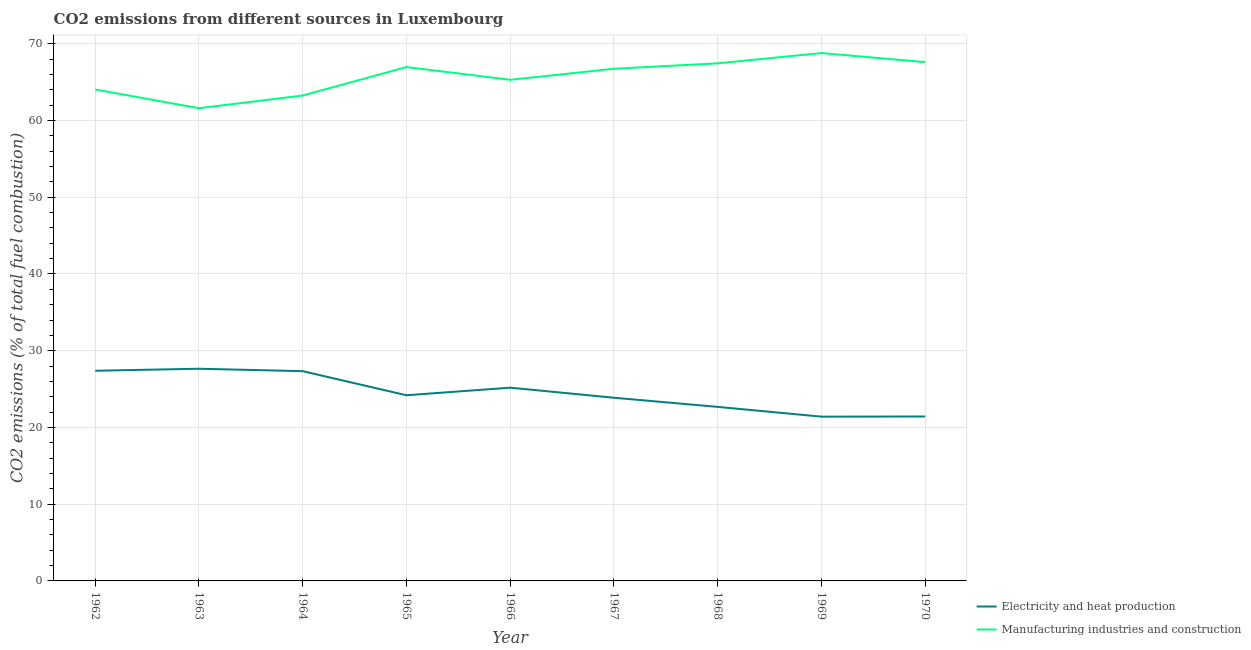What is the co2 emissions due to manufacturing industries in 1969?
Your answer should be very brief. 68.79. Across all years, what is the maximum co2 emissions due to manufacturing industries?
Give a very brief answer. 68.79. Across all years, what is the minimum co2 emissions due to manufacturing industries?
Offer a terse response. 61.6. In which year was the co2 emissions due to manufacturing industries maximum?
Provide a short and direct response. 1969. In which year was the co2 emissions due to manufacturing industries minimum?
Offer a very short reply. 1963. What is the total co2 emissions due to manufacturing industries in the graph?
Offer a terse response. 591.81. What is the difference between the co2 emissions due to manufacturing industries in 1963 and that in 1970?
Your response must be concise. -6.01. What is the difference between the co2 emissions due to electricity and heat production in 1967 and the co2 emissions due to manufacturing industries in 1968?
Offer a very short reply. -43.58. What is the average co2 emissions due to manufacturing industries per year?
Your response must be concise. 65.76. In the year 1970, what is the difference between the co2 emissions due to electricity and heat production and co2 emissions due to manufacturing industries?
Give a very brief answer. -46.19. In how many years, is the co2 emissions due to manufacturing industries greater than 38 %?
Provide a short and direct response. 9. What is the ratio of the co2 emissions due to manufacturing industries in 1965 to that in 1966?
Provide a succinct answer. 1.03. Is the co2 emissions due to manufacturing industries in 1966 less than that in 1968?
Make the answer very short. Yes. Is the difference between the co2 emissions due to manufacturing industries in 1968 and 1970 greater than the difference between the co2 emissions due to electricity and heat production in 1968 and 1970?
Provide a succinct answer. No. What is the difference between the highest and the second highest co2 emissions due to electricity and heat production?
Your answer should be compact. 0.26. What is the difference between the highest and the lowest co2 emissions due to manufacturing industries?
Your answer should be compact. 7.19. In how many years, is the co2 emissions due to electricity and heat production greater than the average co2 emissions due to electricity and heat production taken over all years?
Offer a terse response. 4. Does the co2 emissions due to manufacturing industries monotonically increase over the years?
Offer a very short reply. No. Is the co2 emissions due to electricity and heat production strictly greater than the co2 emissions due to manufacturing industries over the years?
Offer a very short reply. No. Is the co2 emissions due to manufacturing industries strictly less than the co2 emissions due to electricity and heat production over the years?
Your answer should be very brief. No. How many lines are there?
Your answer should be very brief. 2. Does the graph contain any zero values?
Keep it short and to the point. No. What is the title of the graph?
Your response must be concise. CO2 emissions from different sources in Luxembourg. Does "Current education expenditure" appear as one of the legend labels in the graph?
Your response must be concise. No. What is the label or title of the X-axis?
Your answer should be compact. Year. What is the label or title of the Y-axis?
Provide a short and direct response. CO2 emissions (% of total fuel combustion). What is the CO2 emissions (% of total fuel combustion) in Electricity and heat production in 1962?
Your answer should be compact. 27.39. What is the CO2 emissions (% of total fuel combustion) of Manufacturing industries and construction in 1962?
Your response must be concise. 64.05. What is the CO2 emissions (% of total fuel combustion) of Electricity and heat production in 1963?
Make the answer very short. 27.65. What is the CO2 emissions (% of total fuel combustion) in Manufacturing industries and construction in 1963?
Your answer should be compact. 61.6. What is the CO2 emissions (% of total fuel combustion) in Electricity and heat production in 1964?
Offer a very short reply. 27.34. What is the CO2 emissions (% of total fuel combustion) in Manufacturing industries and construction in 1964?
Ensure brevity in your answer.  63.26. What is the CO2 emissions (% of total fuel combustion) in Electricity and heat production in 1965?
Provide a short and direct response. 24.2. What is the CO2 emissions (% of total fuel combustion) of Manufacturing industries and construction in 1965?
Your answer should be very brief. 66.97. What is the CO2 emissions (% of total fuel combustion) of Electricity and heat production in 1966?
Your response must be concise. 25.19. What is the CO2 emissions (% of total fuel combustion) in Manufacturing industries and construction in 1966?
Your answer should be compact. 65.31. What is the CO2 emissions (% of total fuel combustion) of Electricity and heat production in 1967?
Ensure brevity in your answer.  23.87. What is the CO2 emissions (% of total fuel combustion) of Manufacturing industries and construction in 1967?
Your answer should be compact. 66.75. What is the CO2 emissions (% of total fuel combustion) in Electricity and heat production in 1968?
Keep it short and to the point. 22.68. What is the CO2 emissions (% of total fuel combustion) in Manufacturing industries and construction in 1968?
Your answer should be compact. 67.45. What is the CO2 emissions (% of total fuel combustion) in Electricity and heat production in 1969?
Provide a succinct answer. 21.41. What is the CO2 emissions (% of total fuel combustion) of Manufacturing industries and construction in 1969?
Offer a terse response. 68.79. What is the CO2 emissions (% of total fuel combustion) of Electricity and heat production in 1970?
Your answer should be compact. 21.43. What is the CO2 emissions (% of total fuel combustion) of Manufacturing industries and construction in 1970?
Ensure brevity in your answer.  67.62. Across all years, what is the maximum CO2 emissions (% of total fuel combustion) of Electricity and heat production?
Your answer should be compact. 27.65. Across all years, what is the maximum CO2 emissions (% of total fuel combustion) of Manufacturing industries and construction?
Offer a very short reply. 68.79. Across all years, what is the minimum CO2 emissions (% of total fuel combustion) in Electricity and heat production?
Ensure brevity in your answer.  21.41. Across all years, what is the minimum CO2 emissions (% of total fuel combustion) of Manufacturing industries and construction?
Provide a succinct answer. 61.6. What is the total CO2 emissions (% of total fuel combustion) in Electricity and heat production in the graph?
Provide a succinct answer. 221.15. What is the total CO2 emissions (% of total fuel combustion) of Manufacturing industries and construction in the graph?
Provide a succinct answer. 591.81. What is the difference between the CO2 emissions (% of total fuel combustion) in Electricity and heat production in 1962 and that in 1963?
Ensure brevity in your answer.  -0.26. What is the difference between the CO2 emissions (% of total fuel combustion) in Manufacturing industries and construction in 1962 and that in 1963?
Provide a short and direct response. 2.44. What is the difference between the CO2 emissions (% of total fuel combustion) in Electricity and heat production in 1962 and that in 1964?
Your answer should be compact. 0.06. What is the difference between the CO2 emissions (% of total fuel combustion) in Manufacturing industries and construction in 1962 and that in 1964?
Your answer should be very brief. 0.79. What is the difference between the CO2 emissions (% of total fuel combustion) in Electricity and heat production in 1962 and that in 1965?
Make the answer very short. 3.19. What is the difference between the CO2 emissions (% of total fuel combustion) of Manufacturing industries and construction in 1962 and that in 1965?
Provide a short and direct response. -2.92. What is the difference between the CO2 emissions (% of total fuel combustion) in Electricity and heat production in 1962 and that in 1966?
Your response must be concise. 2.21. What is the difference between the CO2 emissions (% of total fuel combustion) in Manufacturing industries and construction in 1962 and that in 1966?
Your answer should be very brief. -1.26. What is the difference between the CO2 emissions (% of total fuel combustion) of Electricity and heat production in 1962 and that in 1967?
Offer a terse response. 3.52. What is the difference between the CO2 emissions (% of total fuel combustion) of Manufacturing industries and construction in 1962 and that in 1967?
Your answer should be very brief. -2.7. What is the difference between the CO2 emissions (% of total fuel combustion) in Electricity and heat production in 1962 and that in 1968?
Provide a succinct answer. 4.71. What is the difference between the CO2 emissions (% of total fuel combustion) in Manufacturing industries and construction in 1962 and that in 1968?
Keep it short and to the point. -3.4. What is the difference between the CO2 emissions (% of total fuel combustion) in Electricity and heat production in 1962 and that in 1969?
Make the answer very short. 5.98. What is the difference between the CO2 emissions (% of total fuel combustion) in Manufacturing industries and construction in 1962 and that in 1969?
Your answer should be very brief. -4.75. What is the difference between the CO2 emissions (% of total fuel combustion) of Electricity and heat production in 1962 and that in 1970?
Make the answer very short. 5.96. What is the difference between the CO2 emissions (% of total fuel combustion) of Manufacturing industries and construction in 1962 and that in 1970?
Make the answer very short. -3.57. What is the difference between the CO2 emissions (% of total fuel combustion) in Electricity and heat production in 1963 and that in 1964?
Offer a very short reply. 0.32. What is the difference between the CO2 emissions (% of total fuel combustion) in Manufacturing industries and construction in 1963 and that in 1964?
Offer a terse response. -1.66. What is the difference between the CO2 emissions (% of total fuel combustion) of Electricity and heat production in 1963 and that in 1965?
Make the answer very short. 3.46. What is the difference between the CO2 emissions (% of total fuel combustion) in Manufacturing industries and construction in 1963 and that in 1965?
Offer a terse response. -5.37. What is the difference between the CO2 emissions (% of total fuel combustion) in Electricity and heat production in 1963 and that in 1966?
Your answer should be very brief. 2.47. What is the difference between the CO2 emissions (% of total fuel combustion) in Manufacturing industries and construction in 1963 and that in 1966?
Your answer should be very brief. -3.7. What is the difference between the CO2 emissions (% of total fuel combustion) of Electricity and heat production in 1963 and that in 1967?
Ensure brevity in your answer.  3.78. What is the difference between the CO2 emissions (% of total fuel combustion) of Manufacturing industries and construction in 1963 and that in 1967?
Ensure brevity in your answer.  -5.14. What is the difference between the CO2 emissions (% of total fuel combustion) of Electricity and heat production in 1963 and that in 1968?
Offer a very short reply. 4.97. What is the difference between the CO2 emissions (% of total fuel combustion) of Manufacturing industries and construction in 1963 and that in 1968?
Offer a terse response. -5.85. What is the difference between the CO2 emissions (% of total fuel combustion) in Electricity and heat production in 1963 and that in 1969?
Offer a very short reply. 6.24. What is the difference between the CO2 emissions (% of total fuel combustion) of Manufacturing industries and construction in 1963 and that in 1969?
Make the answer very short. -7.19. What is the difference between the CO2 emissions (% of total fuel combustion) in Electricity and heat production in 1963 and that in 1970?
Provide a short and direct response. 6.22. What is the difference between the CO2 emissions (% of total fuel combustion) in Manufacturing industries and construction in 1963 and that in 1970?
Give a very brief answer. -6.01. What is the difference between the CO2 emissions (% of total fuel combustion) of Electricity and heat production in 1964 and that in 1965?
Offer a terse response. 3.14. What is the difference between the CO2 emissions (% of total fuel combustion) of Manufacturing industries and construction in 1964 and that in 1965?
Offer a very short reply. -3.71. What is the difference between the CO2 emissions (% of total fuel combustion) of Electricity and heat production in 1964 and that in 1966?
Provide a succinct answer. 2.15. What is the difference between the CO2 emissions (% of total fuel combustion) in Manufacturing industries and construction in 1964 and that in 1966?
Make the answer very short. -2.05. What is the difference between the CO2 emissions (% of total fuel combustion) in Electricity and heat production in 1964 and that in 1967?
Provide a short and direct response. 3.46. What is the difference between the CO2 emissions (% of total fuel combustion) in Manufacturing industries and construction in 1964 and that in 1967?
Ensure brevity in your answer.  -3.49. What is the difference between the CO2 emissions (% of total fuel combustion) in Electricity and heat production in 1964 and that in 1968?
Keep it short and to the point. 4.65. What is the difference between the CO2 emissions (% of total fuel combustion) of Manufacturing industries and construction in 1964 and that in 1968?
Your answer should be very brief. -4.19. What is the difference between the CO2 emissions (% of total fuel combustion) of Electricity and heat production in 1964 and that in 1969?
Your response must be concise. 5.93. What is the difference between the CO2 emissions (% of total fuel combustion) of Manufacturing industries and construction in 1964 and that in 1969?
Keep it short and to the point. -5.53. What is the difference between the CO2 emissions (% of total fuel combustion) of Electricity and heat production in 1964 and that in 1970?
Your answer should be very brief. 5.91. What is the difference between the CO2 emissions (% of total fuel combustion) of Manufacturing industries and construction in 1964 and that in 1970?
Your response must be concise. -4.35. What is the difference between the CO2 emissions (% of total fuel combustion) in Electricity and heat production in 1965 and that in 1966?
Provide a short and direct response. -0.99. What is the difference between the CO2 emissions (% of total fuel combustion) of Manufacturing industries and construction in 1965 and that in 1966?
Give a very brief answer. 1.66. What is the difference between the CO2 emissions (% of total fuel combustion) of Electricity and heat production in 1965 and that in 1967?
Provide a succinct answer. 0.32. What is the difference between the CO2 emissions (% of total fuel combustion) in Manufacturing industries and construction in 1965 and that in 1967?
Provide a short and direct response. 0.22. What is the difference between the CO2 emissions (% of total fuel combustion) in Electricity and heat production in 1965 and that in 1968?
Keep it short and to the point. 1.52. What is the difference between the CO2 emissions (% of total fuel combustion) of Manufacturing industries and construction in 1965 and that in 1968?
Your response must be concise. -0.48. What is the difference between the CO2 emissions (% of total fuel combustion) of Electricity and heat production in 1965 and that in 1969?
Your answer should be compact. 2.79. What is the difference between the CO2 emissions (% of total fuel combustion) of Manufacturing industries and construction in 1965 and that in 1969?
Provide a succinct answer. -1.82. What is the difference between the CO2 emissions (% of total fuel combustion) of Electricity and heat production in 1965 and that in 1970?
Make the answer very short. 2.77. What is the difference between the CO2 emissions (% of total fuel combustion) in Manufacturing industries and construction in 1965 and that in 1970?
Your response must be concise. -0.64. What is the difference between the CO2 emissions (% of total fuel combustion) of Electricity and heat production in 1966 and that in 1967?
Your answer should be very brief. 1.31. What is the difference between the CO2 emissions (% of total fuel combustion) of Manufacturing industries and construction in 1966 and that in 1967?
Keep it short and to the point. -1.44. What is the difference between the CO2 emissions (% of total fuel combustion) of Electricity and heat production in 1966 and that in 1968?
Your answer should be compact. 2.5. What is the difference between the CO2 emissions (% of total fuel combustion) of Manufacturing industries and construction in 1966 and that in 1968?
Give a very brief answer. -2.15. What is the difference between the CO2 emissions (% of total fuel combustion) of Electricity and heat production in 1966 and that in 1969?
Ensure brevity in your answer.  3.78. What is the difference between the CO2 emissions (% of total fuel combustion) in Manufacturing industries and construction in 1966 and that in 1969?
Provide a succinct answer. -3.49. What is the difference between the CO2 emissions (% of total fuel combustion) in Electricity and heat production in 1966 and that in 1970?
Provide a succinct answer. 3.76. What is the difference between the CO2 emissions (% of total fuel combustion) in Manufacturing industries and construction in 1966 and that in 1970?
Give a very brief answer. -2.31. What is the difference between the CO2 emissions (% of total fuel combustion) of Electricity and heat production in 1967 and that in 1968?
Your answer should be very brief. 1.19. What is the difference between the CO2 emissions (% of total fuel combustion) in Manufacturing industries and construction in 1967 and that in 1968?
Provide a short and direct response. -0.71. What is the difference between the CO2 emissions (% of total fuel combustion) of Electricity and heat production in 1967 and that in 1969?
Provide a succinct answer. 2.47. What is the difference between the CO2 emissions (% of total fuel combustion) of Manufacturing industries and construction in 1967 and that in 1969?
Provide a succinct answer. -2.05. What is the difference between the CO2 emissions (% of total fuel combustion) of Electricity and heat production in 1967 and that in 1970?
Provide a short and direct response. 2.45. What is the difference between the CO2 emissions (% of total fuel combustion) in Manufacturing industries and construction in 1967 and that in 1970?
Ensure brevity in your answer.  -0.87. What is the difference between the CO2 emissions (% of total fuel combustion) of Electricity and heat production in 1968 and that in 1969?
Keep it short and to the point. 1.27. What is the difference between the CO2 emissions (% of total fuel combustion) in Manufacturing industries and construction in 1968 and that in 1969?
Provide a short and direct response. -1.34. What is the difference between the CO2 emissions (% of total fuel combustion) in Electricity and heat production in 1968 and that in 1970?
Your answer should be compact. 1.25. What is the difference between the CO2 emissions (% of total fuel combustion) of Manufacturing industries and construction in 1968 and that in 1970?
Offer a very short reply. -0.16. What is the difference between the CO2 emissions (% of total fuel combustion) of Electricity and heat production in 1969 and that in 1970?
Offer a very short reply. -0.02. What is the difference between the CO2 emissions (% of total fuel combustion) in Manufacturing industries and construction in 1969 and that in 1970?
Ensure brevity in your answer.  1.18. What is the difference between the CO2 emissions (% of total fuel combustion) in Electricity and heat production in 1962 and the CO2 emissions (% of total fuel combustion) in Manufacturing industries and construction in 1963?
Offer a very short reply. -34.21. What is the difference between the CO2 emissions (% of total fuel combustion) of Electricity and heat production in 1962 and the CO2 emissions (% of total fuel combustion) of Manufacturing industries and construction in 1964?
Your answer should be very brief. -35.87. What is the difference between the CO2 emissions (% of total fuel combustion) in Electricity and heat production in 1962 and the CO2 emissions (% of total fuel combustion) in Manufacturing industries and construction in 1965?
Provide a short and direct response. -39.58. What is the difference between the CO2 emissions (% of total fuel combustion) of Electricity and heat production in 1962 and the CO2 emissions (% of total fuel combustion) of Manufacturing industries and construction in 1966?
Provide a succinct answer. -37.92. What is the difference between the CO2 emissions (% of total fuel combustion) in Electricity and heat production in 1962 and the CO2 emissions (% of total fuel combustion) in Manufacturing industries and construction in 1967?
Provide a succinct answer. -39.36. What is the difference between the CO2 emissions (% of total fuel combustion) of Electricity and heat production in 1962 and the CO2 emissions (% of total fuel combustion) of Manufacturing industries and construction in 1968?
Keep it short and to the point. -40.06. What is the difference between the CO2 emissions (% of total fuel combustion) of Electricity and heat production in 1962 and the CO2 emissions (% of total fuel combustion) of Manufacturing industries and construction in 1969?
Offer a terse response. -41.4. What is the difference between the CO2 emissions (% of total fuel combustion) of Electricity and heat production in 1962 and the CO2 emissions (% of total fuel combustion) of Manufacturing industries and construction in 1970?
Your response must be concise. -40.22. What is the difference between the CO2 emissions (% of total fuel combustion) in Electricity and heat production in 1963 and the CO2 emissions (% of total fuel combustion) in Manufacturing industries and construction in 1964?
Your response must be concise. -35.61. What is the difference between the CO2 emissions (% of total fuel combustion) in Electricity and heat production in 1963 and the CO2 emissions (% of total fuel combustion) in Manufacturing industries and construction in 1965?
Keep it short and to the point. -39.32. What is the difference between the CO2 emissions (% of total fuel combustion) of Electricity and heat production in 1963 and the CO2 emissions (% of total fuel combustion) of Manufacturing industries and construction in 1966?
Ensure brevity in your answer.  -37.66. What is the difference between the CO2 emissions (% of total fuel combustion) in Electricity and heat production in 1963 and the CO2 emissions (% of total fuel combustion) in Manufacturing industries and construction in 1967?
Your response must be concise. -39.1. What is the difference between the CO2 emissions (% of total fuel combustion) of Electricity and heat production in 1963 and the CO2 emissions (% of total fuel combustion) of Manufacturing industries and construction in 1968?
Offer a very short reply. -39.8. What is the difference between the CO2 emissions (% of total fuel combustion) of Electricity and heat production in 1963 and the CO2 emissions (% of total fuel combustion) of Manufacturing industries and construction in 1969?
Make the answer very short. -41.14. What is the difference between the CO2 emissions (% of total fuel combustion) in Electricity and heat production in 1963 and the CO2 emissions (% of total fuel combustion) in Manufacturing industries and construction in 1970?
Offer a very short reply. -39.96. What is the difference between the CO2 emissions (% of total fuel combustion) in Electricity and heat production in 1964 and the CO2 emissions (% of total fuel combustion) in Manufacturing industries and construction in 1965?
Your answer should be compact. -39.64. What is the difference between the CO2 emissions (% of total fuel combustion) of Electricity and heat production in 1964 and the CO2 emissions (% of total fuel combustion) of Manufacturing industries and construction in 1966?
Your response must be concise. -37.97. What is the difference between the CO2 emissions (% of total fuel combustion) in Electricity and heat production in 1964 and the CO2 emissions (% of total fuel combustion) in Manufacturing industries and construction in 1967?
Offer a very short reply. -39.41. What is the difference between the CO2 emissions (% of total fuel combustion) in Electricity and heat production in 1964 and the CO2 emissions (% of total fuel combustion) in Manufacturing industries and construction in 1968?
Provide a succinct answer. -40.12. What is the difference between the CO2 emissions (% of total fuel combustion) of Electricity and heat production in 1964 and the CO2 emissions (% of total fuel combustion) of Manufacturing industries and construction in 1969?
Offer a terse response. -41.46. What is the difference between the CO2 emissions (% of total fuel combustion) in Electricity and heat production in 1964 and the CO2 emissions (% of total fuel combustion) in Manufacturing industries and construction in 1970?
Offer a very short reply. -40.28. What is the difference between the CO2 emissions (% of total fuel combustion) of Electricity and heat production in 1965 and the CO2 emissions (% of total fuel combustion) of Manufacturing industries and construction in 1966?
Your answer should be compact. -41.11. What is the difference between the CO2 emissions (% of total fuel combustion) of Electricity and heat production in 1965 and the CO2 emissions (% of total fuel combustion) of Manufacturing industries and construction in 1967?
Your answer should be very brief. -42.55. What is the difference between the CO2 emissions (% of total fuel combustion) of Electricity and heat production in 1965 and the CO2 emissions (% of total fuel combustion) of Manufacturing industries and construction in 1968?
Give a very brief answer. -43.26. What is the difference between the CO2 emissions (% of total fuel combustion) of Electricity and heat production in 1965 and the CO2 emissions (% of total fuel combustion) of Manufacturing industries and construction in 1969?
Offer a terse response. -44.6. What is the difference between the CO2 emissions (% of total fuel combustion) of Electricity and heat production in 1965 and the CO2 emissions (% of total fuel combustion) of Manufacturing industries and construction in 1970?
Provide a succinct answer. -43.42. What is the difference between the CO2 emissions (% of total fuel combustion) in Electricity and heat production in 1966 and the CO2 emissions (% of total fuel combustion) in Manufacturing industries and construction in 1967?
Ensure brevity in your answer.  -41.56. What is the difference between the CO2 emissions (% of total fuel combustion) in Electricity and heat production in 1966 and the CO2 emissions (% of total fuel combustion) in Manufacturing industries and construction in 1968?
Offer a very short reply. -42.27. What is the difference between the CO2 emissions (% of total fuel combustion) of Electricity and heat production in 1966 and the CO2 emissions (% of total fuel combustion) of Manufacturing industries and construction in 1969?
Make the answer very short. -43.61. What is the difference between the CO2 emissions (% of total fuel combustion) of Electricity and heat production in 1966 and the CO2 emissions (% of total fuel combustion) of Manufacturing industries and construction in 1970?
Your answer should be very brief. -42.43. What is the difference between the CO2 emissions (% of total fuel combustion) in Electricity and heat production in 1967 and the CO2 emissions (% of total fuel combustion) in Manufacturing industries and construction in 1968?
Ensure brevity in your answer.  -43.58. What is the difference between the CO2 emissions (% of total fuel combustion) in Electricity and heat production in 1967 and the CO2 emissions (% of total fuel combustion) in Manufacturing industries and construction in 1969?
Your answer should be very brief. -44.92. What is the difference between the CO2 emissions (% of total fuel combustion) of Electricity and heat production in 1967 and the CO2 emissions (% of total fuel combustion) of Manufacturing industries and construction in 1970?
Provide a succinct answer. -43.74. What is the difference between the CO2 emissions (% of total fuel combustion) of Electricity and heat production in 1968 and the CO2 emissions (% of total fuel combustion) of Manufacturing industries and construction in 1969?
Your response must be concise. -46.11. What is the difference between the CO2 emissions (% of total fuel combustion) of Electricity and heat production in 1968 and the CO2 emissions (% of total fuel combustion) of Manufacturing industries and construction in 1970?
Keep it short and to the point. -44.93. What is the difference between the CO2 emissions (% of total fuel combustion) of Electricity and heat production in 1969 and the CO2 emissions (% of total fuel combustion) of Manufacturing industries and construction in 1970?
Offer a terse response. -46.21. What is the average CO2 emissions (% of total fuel combustion) of Electricity and heat production per year?
Your response must be concise. 24.57. What is the average CO2 emissions (% of total fuel combustion) in Manufacturing industries and construction per year?
Your response must be concise. 65.76. In the year 1962, what is the difference between the CO2 emissions (% of total fuel combustion) of Electricity and heat production and CO2 emissions (% of total fuel combustion) of Manufacturing industries and construction?
Your answer should be very brief. -36.66. In the year 1963, what is the difference between the CO2 emissions (% of total fuel combustion) in Electricity and heat production and CO2 emissions (% of total fuel combustion) in Manufacturing industries and construction?
Your response must be concise. -33.95. In the year 1964, what is the difference between the CO2 emissions (% of total fuel combustion) in Electricity and heat production and CO2 emissions (% of total fuel combustion) in Manufacturing industries and construction?
Your answer should be very brief. -35.92. In the year 1965, what is the difference between the CO2 emissions (% of total fuel combustion) in Electricity and heat production and CO2 emissions (% of total fuel combustion) in Manufacturing industries and construction?
Offer a terse response. -42.78. In the year 1966, what is the difference between the CO2 emissions (% of total fuel combustion) of Electricity and heat production and CO2 emissions (% of total fuel combustion) of Manufacturing industries and construction?
Give a very brief answer. -40.12. In the year 1967, what is the difference between the CO2 emissions (% of total fuel combustion) in Electricity and heat production and CO2 emissions (% of total fuel combustion) in Manufacturing industries and construction?
Make the answer very short. -42.87. In the year 1968, what is the difference between the CO2 emissions (% of total fuel combustion) of Electricity and heat production and CO2 emissions (% of total fuel combustion) of Manufacturing industries and construction?
Ensure brevity in your answer.  -44.77. In the year 1969, what is the difference between the CO2 emissions (% of total fuel combustion) in Electricity and heat production and CO2 emissions (% of total fuel combustion) in Manufacturing industries and construction?
Your answer should be compact. -47.39. In the year 1970, what is the difference between the CO2 emissions (% of total fuel combustion) of Electricity and heat production and CO2 emissions (% of total fuel combustion) of Manufacturing industries and construction?
Provide a succinct answer. -46.19. What is the ratio of the CO2 emissions (% of total fuel combustion) of Manufacturing industries and construction in 1962 to that in 1963?
Provide a short and direct response. 1.04. What is the ratio of the CO2 emissions (% of total fuel combustion) in Manufacturing industries and construction in 1962 to that in 1964?
Keep it short and to the point. 1.01. What is the ratio of the CO2 emissions (% of total fuel combustion) of Electricity and heat production in 1962 to that in 1965?
Your response must be concise. 1.13. What is the ratio of the CO2 emissions (% of total fuel combustion) in Manufacturing industries and construction in 1962 to that in 1965?
Your response must be concise. 0.96. What is the ratio of the CO2 emissions (% of total fuel combustion) in Electricity and heat production in 1962 to that in 1966?
Your answer should be very brief. 1.09. What is the ratio of the CO2 emissions (% of total fuel combustion) of Manufacturing industries and construction in 1962 to that in 1966?
Your answer should be very brief. 0.98. What is the ratio of the CO2 emissions (% of total fuel combustion) of Electricity and heat production in 1962 to that in 1967?
Your response must be concise. 1.15. What is the ratio of the CO2 emissions (% of total fuel combustion) in Manufacturing industries and construction in 1962 to that in 1967?
Offer a very short reply. 0.96. What is the ratio of the CO2 emissions (% of total fuel combustion) in Electricity and heat production in 1962 to that in 1968?
Ensure brevity in your answer.  1.21. What is the ratio of the CO2 emissions (% of total fuel combustion) in Manufacturing industries and construction in 1962 to that in 1968?
Your answer should be compact. 0.95. What is the ratio of the CO2 emissions (% of total fuel combustion) in Electricity and heat production in 1962 to that in 1969?
Provide a short and direct response. 1.28. What is the ratio of the CO2 emissions (% of total fuel combustion) in Manufacturing industries and construction in 1962 to that in 1969?
Offer a terse response. 0.93. What is the ratio of the CO2 emissions (% of total fuel combustion) of Electricity and heat production in 1962 to that in 1970?
Give a very brief answer. 1.28. What is the ratio of the CO2 emissions (% of total fuel combustion) in Manufacturing industries and construction in 1962 to that in 1970?
Give a very brief answer. 0.95. What is the ratio of the CO2 emissions (% of total fuel combustion) in Electricity and heat production in 1963 to that in 1964?
Your answer should be compact. 1.01. What is the ratio of the CO2 emissions (% of total fuel combustion) in Manufacturing industries and construction in 1963 to that in 1964?
Offer a terse response. 0.97. What is the ratio of the CO2 emissions (% of total fuel combustion) in Electricity and heat production in 1963 to that in 1965?
Ensure brevity in your answer.  1.14. What is the ratio of the CO2 emissions (% of total fuel combustion) in Manufacturing industries and construction in 1963 to that in 1965?
Your answer should be very brief. 0.92. What is the ratio of the CO2 emissions (% of total fuel combustion) of Electricity and heat production in 1963 to that in 1966?
Offer a terse response. 1.1. What is the ratio of the CO2 emissions (% of total fuel combustion) of Manufacturing industries and construction in 1963 to that in 1966?
Offer a terse response. 0.94. What is the ratio of the CO2 emissions (% of total fuel combustion) of Electricity and heat production in 1963 to that in 1967?
Offer a terse response. 1.16. What is the ratio of the CO2 emissions (% of total fuel combustion) of Manufacturing industries and construction in 1963 to that in 1967?
Make the answer very short. 0.92. What is the ratio of the CO2 emissions (% of total fuel combustion) in Electricity and heat production in 1963 to that in 1968?
Offer a terse response. 1.22. What is the ratio of the CO2 emissions (% of total fuel combustion) in Manufacturing industries and construction in 1963 to that in 1968?
Your answer should be very brief. 0.91. What is the ratio of the CO2 emissions (% of total fuel combustion) in Electricity and heat production in 1963 to that in 1969?
Your response must be concise. 1.29. What is the ratio of the CO2 emissions (% of total fuel combustion) in Manufacturing industries and construction in 1963 to that in 1969?
Keep it short and to the point. 0.9. What is the ratio of the CO2 emissions (% of total fuel combustion) of Electricity and heat production in 1963 to that in 1970?
Your response must be concise. 1.29. What is the ratio of the CO2 emissions (% of total fuel combustion) of Manufacturing industries and construction in 1963 to that in 1970?
Offer a very short reply. 0.91. What is the ratio of the CO2 emissions (% of total fuel combustion) of Electricity and heat production in 1964 to that in 1965?
Offer a terse response. 1.13. What is the ratio of the CO2 emissions (% of total fuel combustion) in Manufacturing industries and construction in 1964 to that in 1965?
Your answer should be very brief. 0.94. What is the ratio of the CO2 emissions (% of total fuel combustion) of Electricity and heat production in 1964 to that in 1966?
Provide a succinct answer. 1.09. What is the ratio of the CO2 emissions (% of total fuel combustion) of Manufacturing industries and construction in 1964 to that in 1966?
Your response must be concise. 0.97. What is the ratio of the CO2 emissions (% of total fuel combustion) in Electricity and heat production in 1964 to that in 1967?
Keep it short and to the point. 1.15. What is the ratio of the CO2 emissions (% of total fuel combustion) of Manufacturing industries and construction in 1964 to that in 1967?
Make the answer very short. 0.95. What is the ratio of the CO2 emissions (% of total fuel combustion) in Electricity and heat production in 1964 to that in 1968?
Make the answer very short. 1.21. What is the ratio of the CO2 emissions (% of total fuel combustion) of Manufacturing industries and construction in 1964 to that in 1968?
Your response must be concise. 0.94. What is the ratio of the CO2 emissions (% of total fuel combustion) in Electricity and heat production in 1964 to that in 1969?
Provide a succinct answer. 1.28. What is the ratio of the CO2 emissions (% of total fuel combustion) of Manufacturing industries and construction in 1964 to that in 1969?
Ensure brevity in your answer.  0.92. What is the ratio of the CO2 emissions (% of total fuel combustion) in Electricity and heat production in 1964 to that in 1970?
Your response must be concise. 1.28. What is the ratio of the CO2 emissions (% of total fuel combustion) of Manufacturing industries and construction in 1964 to that in 1970?
Make the answer very short. 0.94. What is the ratio of the CO2 emissions (% of total fuel combustion) in Electricity and heat production in 1965 to that in 1966?
Provide a succinct answer. 0.96. What is the ratio of the CO2 emissions (% of total fuel combustion) in Manufacturing industries and construction in 1965 to that in 1966?
Offer a terse response. 1.03. What is the ratio of the CO2 emissions (% of total fuel combustion) of Electricity and heat production in 1965 to that in 1967?
Offer a very short reply. 1.01. What is the ratio of the CO2 emissions (% of total fuel combustion) in Manufacturing industries and construction in 1965 to that in 1967?
Make the answer very short. 1. What is the ratio of the CO2 emissions (% of total fuel combustion) in Electricity and heat production in 1965 to that in 1968?
Offer a terse response. 1.07. What is the ratio of the CO2 emissions (% of total fuel combustion) in Manufacturing industries and construction in 1965 to that in 1968?
Provide a short and direct response. 0.99. What is the ratio of the CO2 emissions (% of total fuel combustion) of Electricity and heat production in 1965 to that in 1969?
Provide a short and direct response. 1.13. What is the ratio of the CO2 emissions (% of total fuel combustion) of Manufacturing industries and construction in 1965 to that in 1969?
Your answer should be very brief. 0.97. What is the ratio of the CO2 emissions (% of total fuel combustion) in Electricity and heat production in 1965 to that in 1970?
Offer a very short reply. 1.13. What is the ratio of the CO2 emissions (% of total fuel combustion) of Electricity and heat production in 1966 to that in 1967?
Provide a short and direct response. 1.05. What is the ratio of the CO2 emissions (% of total fuel combustion) of Manufacturing industries and construction in 1966 to that in 1967?
Your answer should be compact. 0.98. What is the ratio of the CO2 emissions (% of total fuel combustion) of Electricity and heat production in 1966 to that in 1968?
Give a very brief answer. 1.11. What is the ratio of the CO2 emissions (% of total fuel combustion) of Manufacturing industries and construction in 1966 to that in 1968?
Your response must be concise. 0.97. What is the ratio of the CO2 emissions (% of total fuel combustion) in Electricity and heat production in 1966 to that in 1969?
Give a very brief answer. 1.18. What is the ratio of the CO2 emissions (% of total fuel combustion) of Manufacturing industries and construction in 1966 to that in 1969?
Make the answer very short. 0.95. What is the ratio of the CO2 emissions (% of total fuel combustion) of Electricity and heat production in 1966 to that in 1970?
Your response must be concise. 1.18. What is the ratio of the CO2 emissions (% of total fuel combustion) in Manufacturing industries and construction in 1966 to that in 1970?
Offer a terse response. 0.97. What is the ratio of the CO2 emissions (% of total fuel combustion) of Electricity and heat production in 1967 to that in 1968?
Offer a very short reply. 1.05. What is the ratio of the CO2 emissions (% of total fuel combustion) in Manufacturing industries and construction in 1967 to that in 1968?
Your answer should be compact. 0.99. What is the ratio of the CO2 emissions (% of total fuel combustion) of Electricity and heat production in 1967 to that in 1969?
Provide a succinct answer. 1.12. What is the ratio of the CO2 emissions (% of total fuel combustion) in Manufacturing industries and construction in 1967 to that in 1969?
Provide a short and direct response. 0.97. What is the ratio of the CO2 emissions (% of total fuel combustion) in Electricity and heat production in 1967 to that in 1970?
Your response must be concise. 1.11. What is the ratio of the CO2 emissions (% of total fuel combustion) in Manufacturing industries and construction in 1967 to that in 1970?
Offer a very short reply. 0.99. What is the ratio of the CO2 emissions (% of total fuel combustion) in Electricity and heat production in 1968 to that in 1969?
Make the answer very short. 1.06. What is the ratio of the CO2 emissions (% of total fuel combustion) in Manufacturing industries and construction in 1968 to that in 1969?
Keep it short and to the point. 0.98. What is the ratio of the CO2 emissions (% of total fuel combustion) of Electricity and heat production in 1968 to that in 1970?
Provide a short and direct response. 1.06. What is the ratio of the CO2 emissions (% of total fuel combustion) of Manufacturing industries and construction in 1968 to that in 1970?
Offer a terse response. 1. What is the ratio of the CO2 emissions (% of total fuel combustion) in Manufacturing industries and construction in 1969 to that in 1970?
Your response must be concise. 1.02. What is the difference between the highest and the second highest CO2 emissions (% of total fuel combustion) of Electricity and heat production?
Give a very brief answer. 0.26. What is the difference between the highest and the second highest CO2 emissions (% of total fuel combustion) in Manufacturing industries and construction?
Offer a very short reply. 1.18. What is the difference between the highest and the lowest CO2 emissions (% of total fuel combustion) of Electricity and heat production?
Provide a short and direct response. 6.24. What is the difference between the highest and the lowest CO2 emissions (% of total fuel combustion) of Manufacturing industries and construction?
Ensure brevity in your answer.  7.19. 